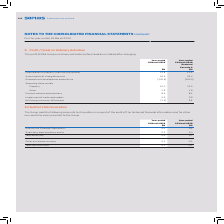According to Sophos Group's financial document, What is stated after charging the items in the table? The profit (2018: loss) on ordinary activities before taxation. The document states: "The profit (2018: loss) on ordinary activities before taxation is stated after charging:..." Also, What was the amount of Depreciation of property, plant and equipment in 2019? According to the financial document, 11.8 (in millions). The relevant text states: "Depreciation of property, plant and equipment 11.8 11.6..." Also, What are the components under Operating lease rentals in the table? The document shows two values: Property and Other. From the document: "Other 1.6 1.6 Depreciation of property, plant and equipment 11.8 11.6..." Additionally, In which year was the amount of Property larger? According to the financial document, 2019. The relevant text states: "For the year-ended 31 March 2019..." Also, can you calculate: What was the change in the amount of Property in 2019 from 2018? Based on the calculation: 14.0-12.5, the result is 1.5 (in millions). This is based on the information: "Property 14.0 12.5 Property 14.0 12.5..." The key data points involved are: 12.5, 14.0. Also, can you calculate: What was the percentage change in the amount of Property in 2019 from 2018? To answer this question, I need to perform calculations using the financial data. The calculation is: (14.0-12.5)/12.5, which equals 12 (percentage). This is based on the information: "Property 14.0 12.5 Property 14.0 12.5..." The key data points involved are: 12.5, 14.0. 